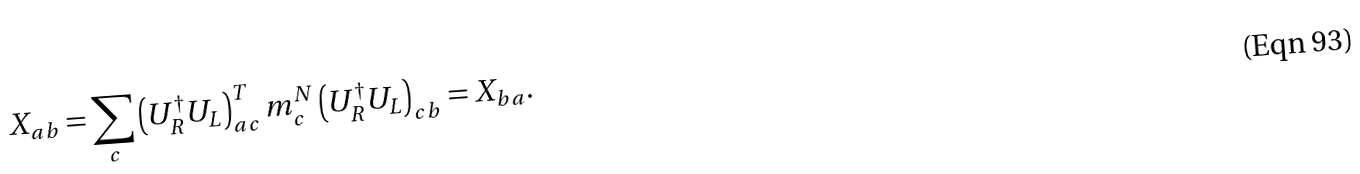Convert formula to latex. <formula><loc_0><loc_0><loc_500><loc_500>X _ { a b } = \sum _ { c } \left ( U _ { R } ^ { \dagger } U _ { L } \right ) ^ { T } _ { a c } m _ { c } ^ { N } \left ( U _ { R } ^ { \dagger } U _ { L } \right ) _ { c b } = X _ { b a } .</formula> 